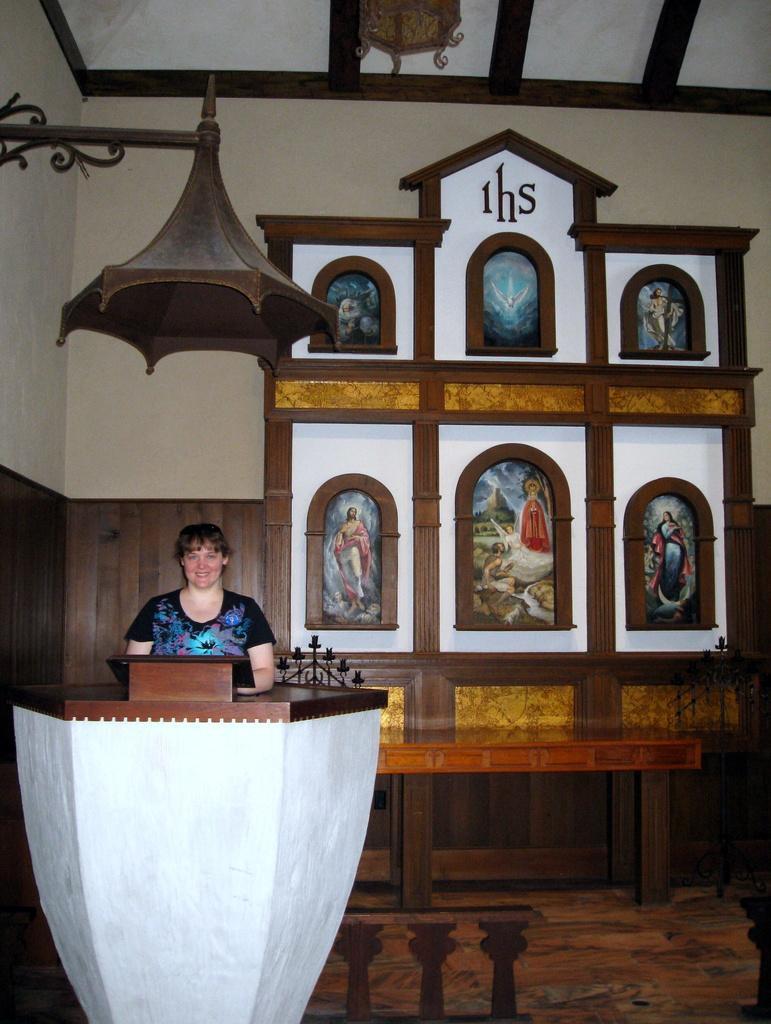Could you give a brief overview of what you see in this image? This image consists of a woman standing near the podium. She is wearing a black T-shirt. In the background, we can see frames fixed on the wall. On the left, there is a light fixed to the wall. At the top, there is a roof. At the bottom, there is a floor. 